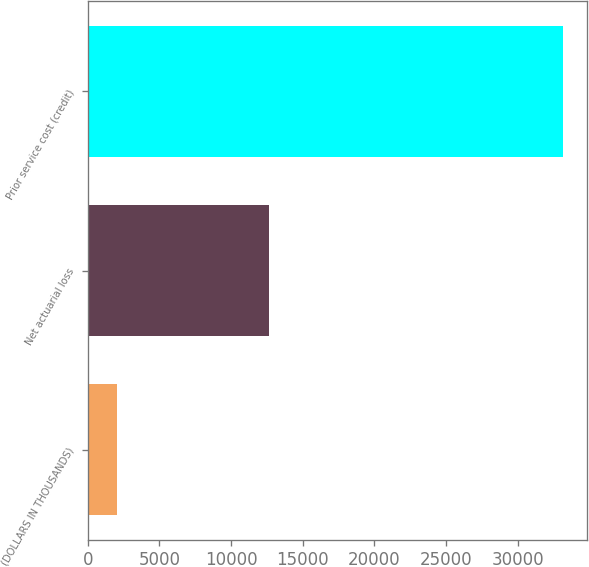Convert chart to OTSL. <chart><loc_0><loc_0><loc_500><loc_500><bar_chart><fcel>(DOLLARS IN THOUSANDS)<fcel>Net actuarial loss<fcel>Prior service cost (credit)<nl><fcel>2018<fcel>12627<fcel>33189<nl></chart> 